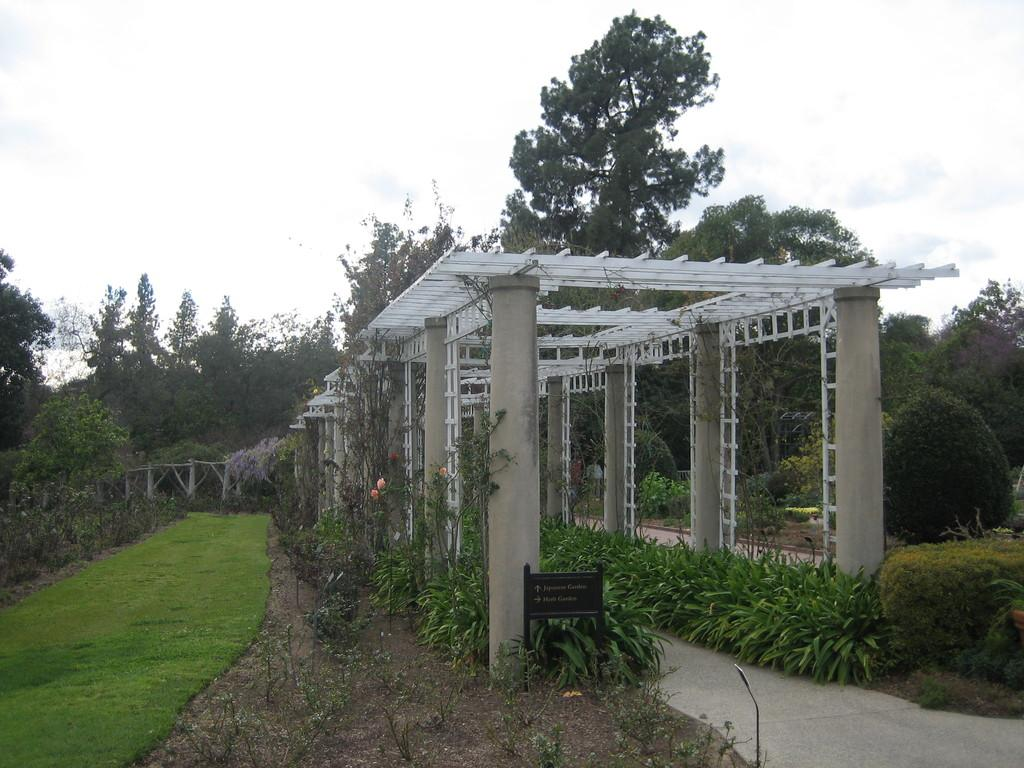What architectural features are present in the image? There are pillars in the image. What type of vegetation can be seen in the image? There are plants and grass in the image. What is visible in the background of the image? There are trees and the sky in the background of the image. What type of lunch is being served in the image? There is no lunch present in the image; it features pillars, plants, grass, trees, and the sky. Can you tell me where the church is located in the image? There is no church present in the image. 